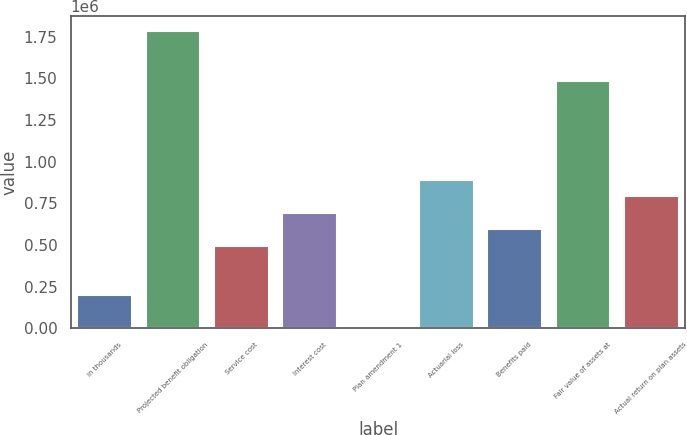Convert chart. <chart><loc_0><loc_0><loc_500><loc_500><bar_chart><fcel>in thousands<fcel>Projected benefit obligation<fcel>Service cost<fcel>Interest cost<fcel>Plan amendment 1<fcel>Actuarial loss<fcel>Benefits paid<fcel>Fair value of assets at<fcel>Actual return on plan assets<nl><fcel>199296<fcel>1.78338e+06<fcel>496312<fcel>694322<fcel>1286<fcel>892333<fcel>595317<fcel>1.48636e+06<fcel>793328<nl></chart> 